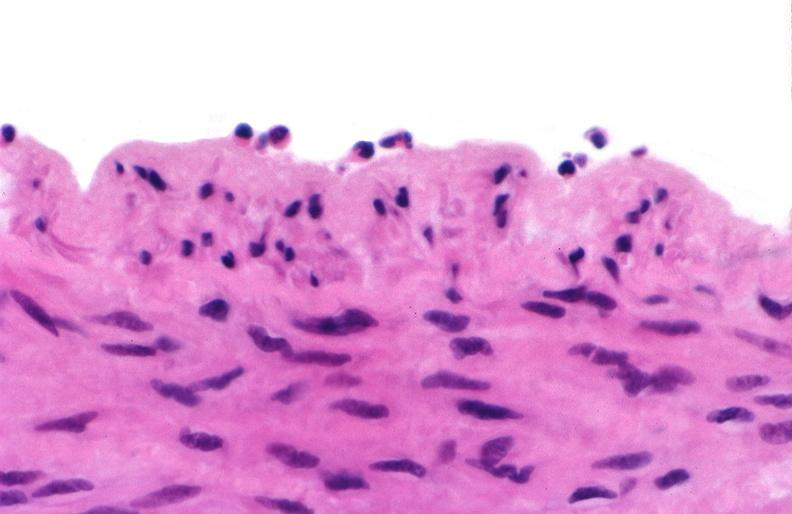s cardiovascular present?
Answer the question using a single word or phrase. Yes 